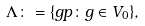<formula> <loc_0><loc_0><loc_500><loc_500>\Lambda \colon = \{ g p \colon g \in V _ { 0 } \} ,</formula> 